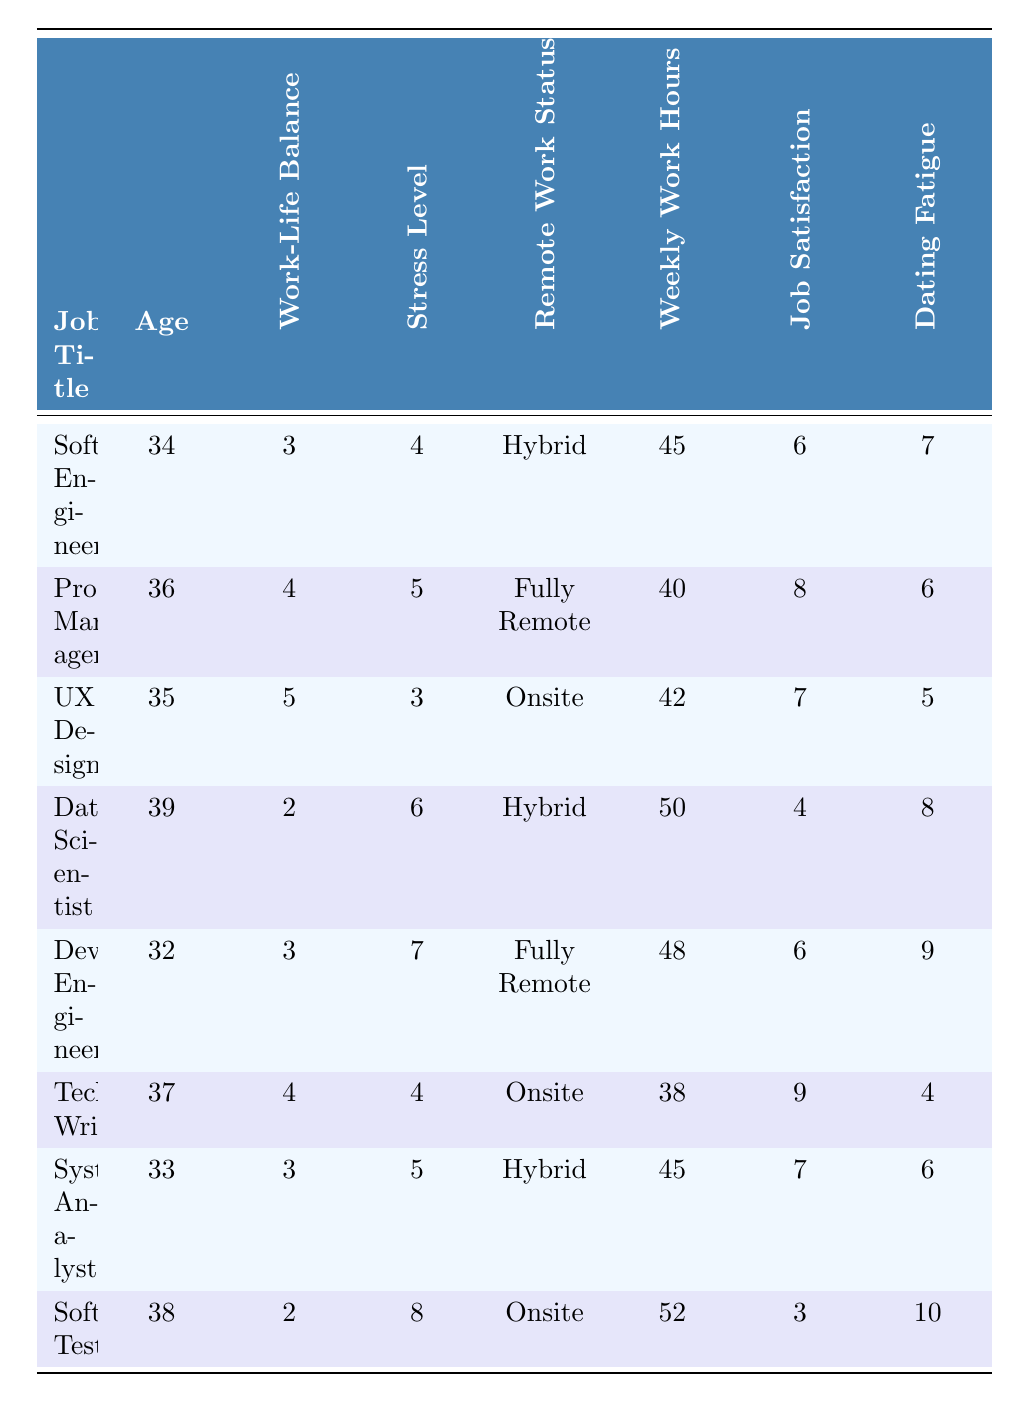What is the job title of the respondent with the highest stress level? The highest stress level is 8, which corresponds to the Software Tester job title in the table.
Answer: Software Tester What is the age of the Product Manager? The age of the respondent who is a Product Manager is 36, as stated in the table.
Answer: 36 How many respondents have a work-life balance rating of 3? There are three respondents (Software Engineer, DevOps Engineer, Systems Analyst) with a work-life balance rating of 3.
Answer: 3 What is the average number of weekly work hours of respondents who work onsite? The weekly work hours for onsite respondents are 42 (UX Designer) + 38 (Technical Writer) + 52 (Software Tester) = 132. There are three onsite respondents, so the average is 132 / 3 = 44.
Answer: 44 Is there a respondent who works fully remote and reports a dating fatigue level of 6 or lower? Yes, the Product Manager works fully remote and has a dating fatigue level of 6.
Answer: Yes What is the difference in job satisfaction ratings between the Software Engineer and the Data Scientist? The Software Engineer has a job satisfaction rating of 6 and the Data Scientist has a rating of 4. The difference is 6 - 4 = 2.
Answer: 2 What is the maximum weekly work hours reported, and which job title does it correspond to? The maximum weekly work hours reported is 52, which corresponds to the Software Tester job title.
Answer: Software Tester Among respondents with a stress level of 5 or higher, which one has the lowest job satisfaction rating? The respondents with a stress level of 5 or higher are the Data Scientist (6 rating - lowest), DevOps Engineer (6 rating), and Software Tester (3 rating). Comparing them, the Software Tester has the lowest job satisfaction rating of 3.
Answer: Software Tester What is the median work-life balance rating of all respondents? The work-life balance ratings, when sorted, are 2, 2, 3, 3, 3, 4, 4, 5. The median (middle value) is the average of the 4th and 5th values: (3 + 4) / 2 = 3.5.
Answer: 3.5 How many respondents report a job satisfaction rating of 4 or lower? There are two respondents (Data Scientist and Software Tester) with job satisfaction ratings of 4 or lower.
Answer: 2 